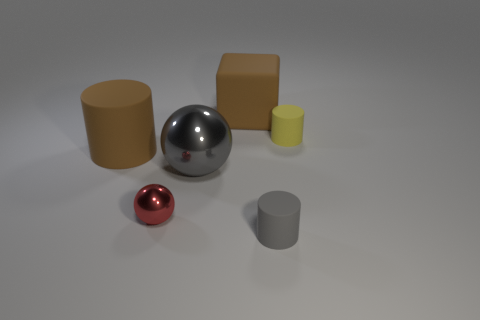There is a cube that is the same color as the big rubber cylinder; what size is it?
Give a very brief answer. Large. Is there any other thing that has the same size as the cube?
Ensure brevity in your answer.  Yes. Do the large gray ball and the big brown cube have the same material?
Give a very brief answer. No. What number of objects are large brown matte objects that are in front of the matte cube or gray things on the right side of the big brown matte cube?
Give a very brief answer. 2. Are there any purple shiny things of the same size as the brown block?
Your answer should be compact. No. The other thing that is the same shape as the gray metal object is what color?
Provide a short and direct response. Red. Are there any objects on the right side of the gray object that is behind the small gray thing?
Provide a short and direct response. Yes. There is a brown thing left of the large metallic sphere; is it the same shape as the yellow object?
Offer a very short reply. Yes. What shape is the tiny red object?
Offer a very short reply. Sphere. How many gray spheres are the same material as the big block?
Keep it short and to the point. 0. 